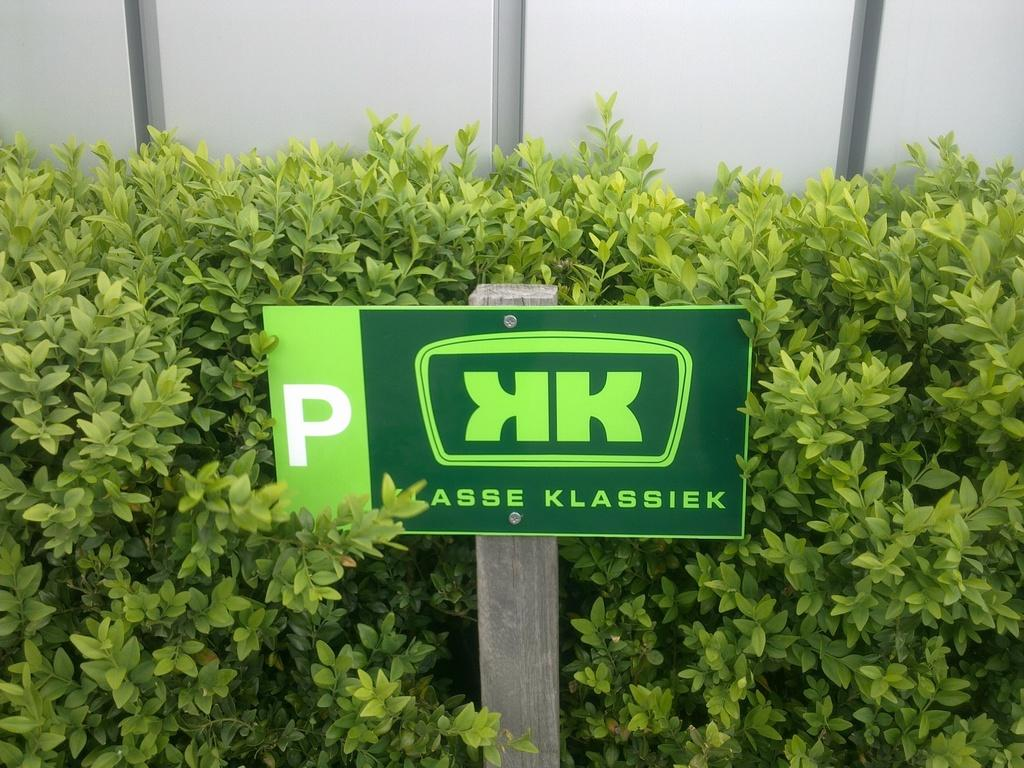What color is the board in the image? The board is green. What can be found on the green board? There are plants on the board. How many steel bikes are parked in the store near the green board? There is no information about steel bikes or a store in the image, so we cannot answer this question. 